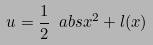<formula> <loc_0><loc_0><loc_500><loc_500>u = \frac { 1 } { 2 } \ a b s { x } ^ { 2 } + l ( x )</formula> 